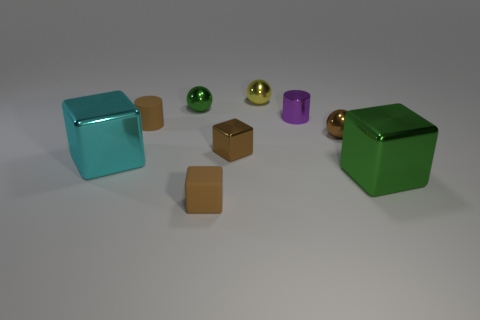What shape is the rubber thing that is the same color as the rubber block?
Make the answer very short. Cylinder. Do the small rubber block on the right side of the cyan shiny object and the tiny matte cylinder have the same color?
Keep it short and to the point. Yes. Do the rubber cylinder and the small shiny cube have the same color?
Make the answer very short. Yes. What is the size of the block that is right of the tiny metal ball that is in front of the tiny green thing?
Keep it short and to the point. Large. There is a cyan object that is to the left of the green metal cube; does it have the same size as the metal cylinder?
Your answer should be very brief. No. Are there more shiny blocks that are to the left of the small green thing than big metal things to the right of the big green shiny cube?
Ensure brevity in your answer.  Yes. The tiny object that is both in front of the tiny purple cylinder and on the left side of the matte cube has what shape?
Offer a very short reply. Cylinder. There is a small metallic thing that is behind the small green thing; what shape is it?
Your response must be concise. Sphere. How big is the green shiny thing that is right of the small metal sphere that is on the left side of the tiny brown rubber thing that is in front of the cyan thing?
Give a very brief answer. Large. Is the tiny green shiny thing the same shape as the yellow object?
Give a very brief answer. Yes. 